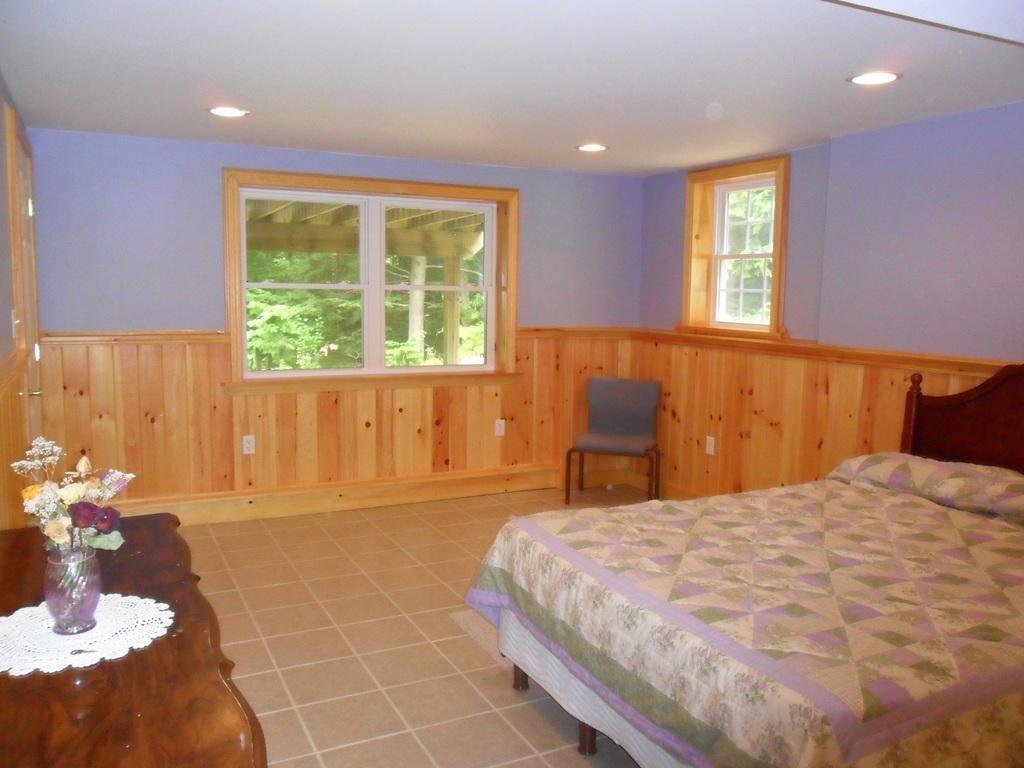Can you describe this image briefly? This picture is of inside the room. On the right there is a bed. On the left we can see a table on the top of which a flower vase is placed. In the background we can see a wall, two windows, chair and through the window we can see the outside view containing trees and plants. 